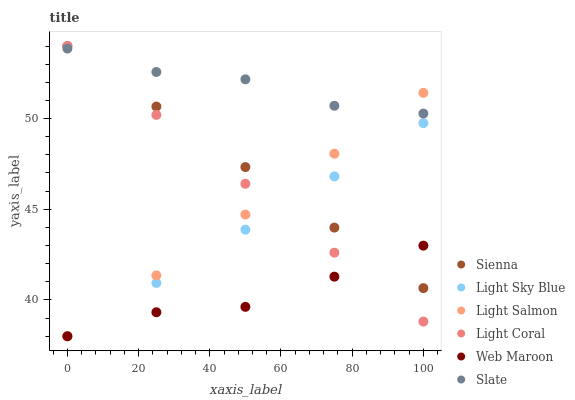Does Web Maroon have the minimum area under the curve?
Answer yes or no. Yes. Does Slate have the maximum area under the curve?
Answer yes or no. Yes. Does Light Salmon have the minimum area under the curve?
Answer yes or no. No. Does Light Salmon have the maximum area under the curve?
Answer yes or no. No. Is Light Coral the smoothest?
Answer yes or no. Yes. Is Slate the roughest?
Answer yes or no. Yes. Is Slate the smoothest?
Answer yes or no. No. Is Light Salmon the roughest?
Answer yes or no. No. Does Light Salmon have the lowest value?
Answer yes or no. Yes. Does Slate have the lowest value?
Answer yes or no. No. Does Sienna have the highest value?
Answer yes or no. Yes. Does Light Salmon have the highest value?
Answer yes or no. No. Is Light Sky Blue less than Slate?
Answer yes or no. Yes. Is Slate greater than Web Maroon?
Answer yes or no. Yes. Does Sienna intersect Light Salmon?
Answer yes or no. Yes. Is Sienna less than Light Salmon?
Answer yes or no. No. Is Sienna greater than Light Salmon?
Answer yes or no. No. Does Light Sky Blue intersect Slate?
Answer yes or no. No. 